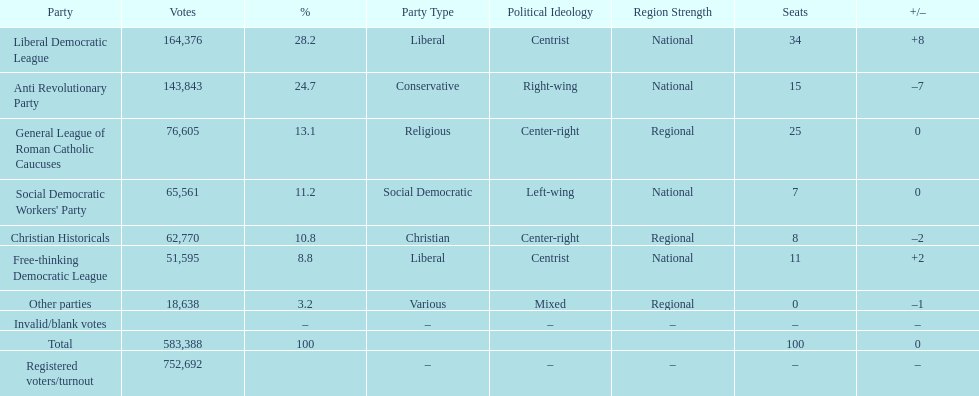Name the top three parties? Liberal Democratic League, Anti Revolutionary Party, General League of Roman Catholic Caucuses. 